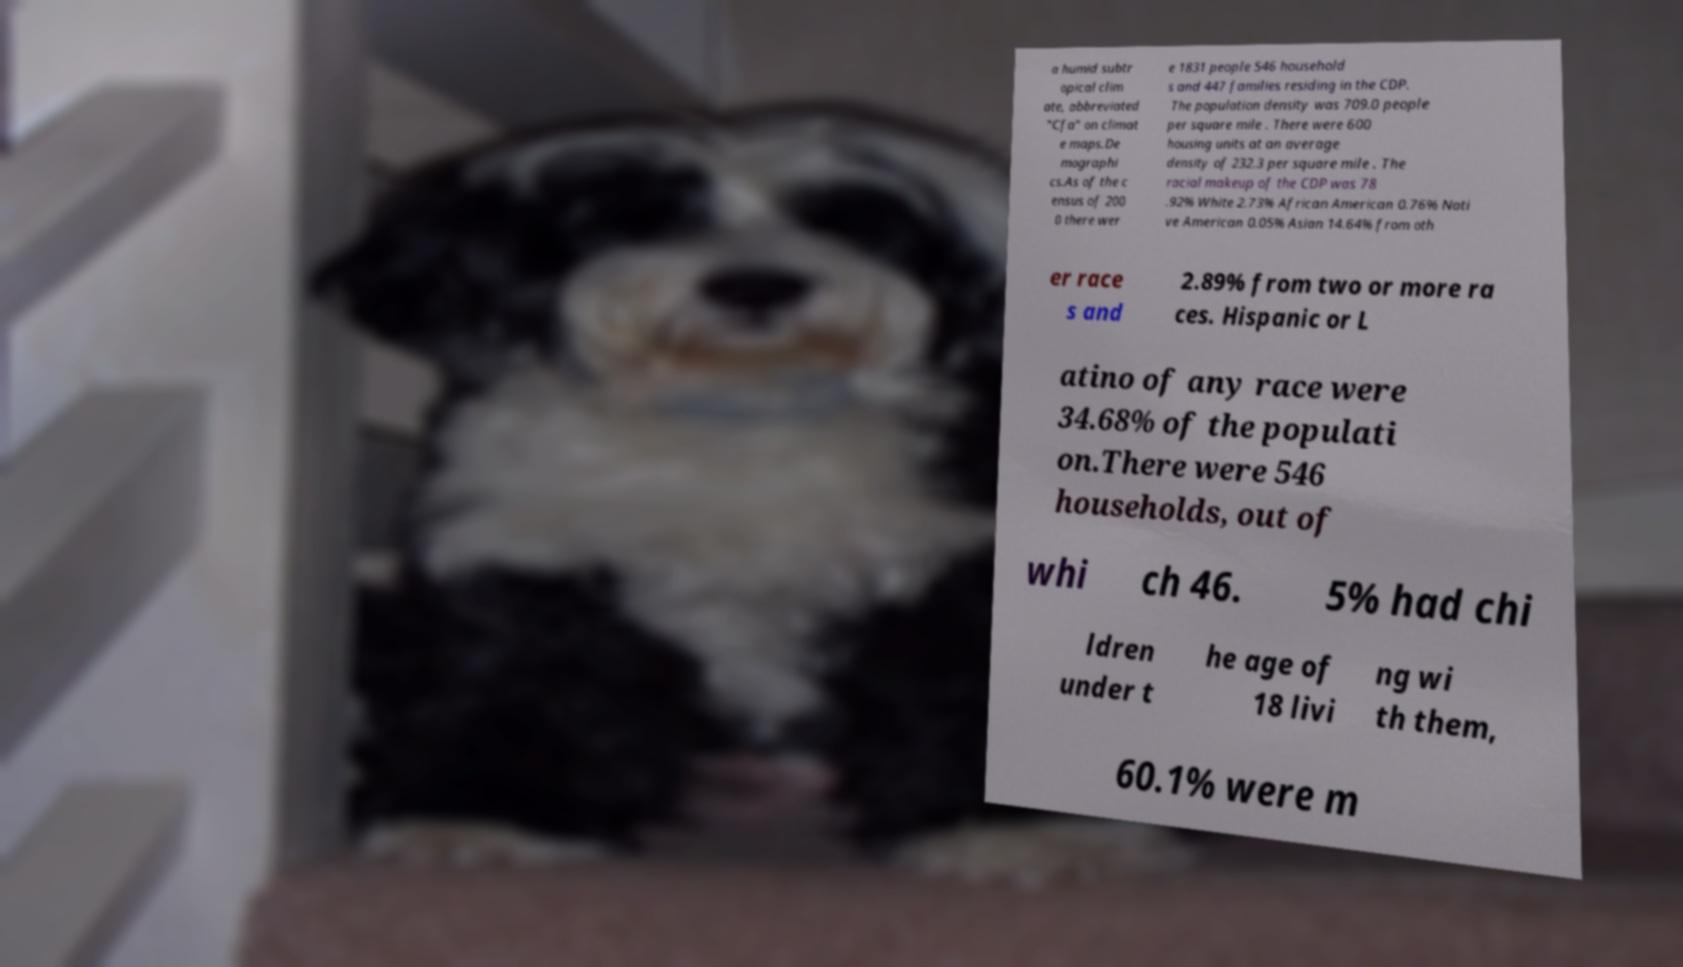For documentation purposes, I need the text within this image transcribed. Could you provide that? a humid subtr opical clim ate, abbreviated "Cfa" on climat e maps.De mographi cs.As of the c ensus of 200 0 there wer e 1831 people 546 household s and 447 families residing in the CDP. The population density was 709.0 people per square mile . There were 600 housing units at an average density of 232.3 per square mile . The racial makeup of the CDP was 78 .92% White 2.73% African American 0.76% Nati ve American 0.05% Asian 14.64% from oth er race s and 2.89% from two or more ra ces. Hispanic or L atino of any race were 34.68% of the populati on.There were 546 households, out of whi ch 46. 5% had chi ldren under t he age of 18 livi ng wi th them, 60.1% were m 